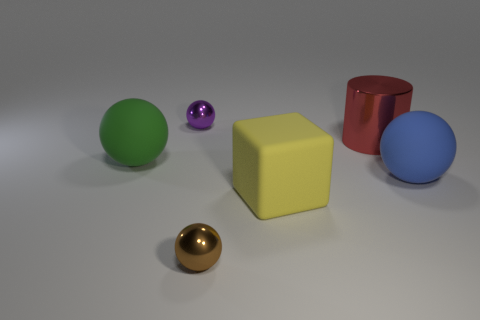What materials do these objects seem to be made of? The objects appear to be rendered with different materials. The green and blue objects have a matte surface suggesting they could be made of plastic. The yellow cube has a slightly textured surface, indicating it might be a rubber material. The red object has a reflective surface, implying a metallic or plastic material with a glossy finish. The purple and golden spheres also have shiny surfaces, suggesting they could be made of polished metal or glass. 